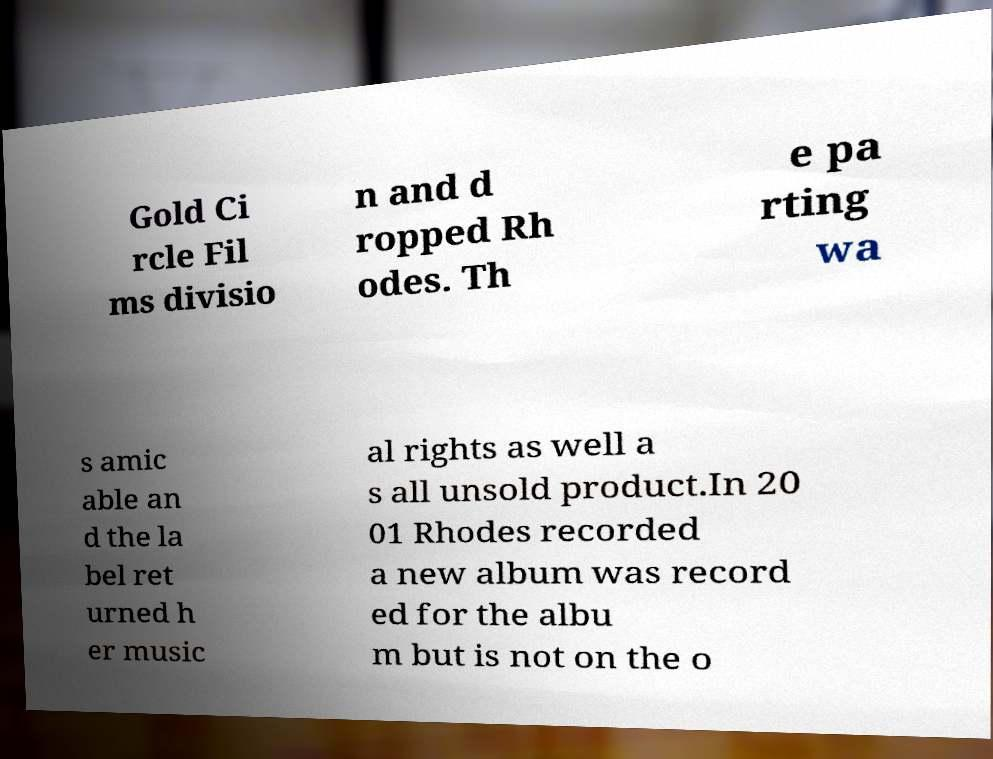Please identify and transcribe the text found in this image. Gold Ci rcle Fil ms divisio n and d ropped Rh odes. Th e pa rting wa s amic able an d the la bel ret urned h er music al rights as well a s all unsold product.In 20 01 Rhodes recorded a new album was record ed for the albu m but is not on the o 